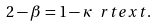<formula> <loc_0><loc_0><loc_500><loc_500>2 - \beta = 1 - \kappa \ r t e x t { . }</formula> 